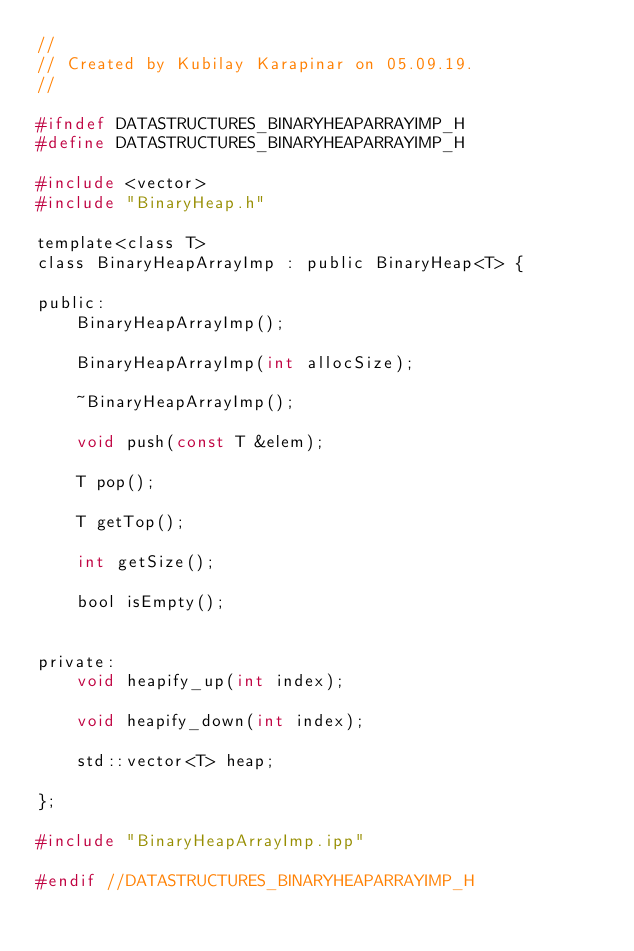Convert code to text. <code><loc_0><loc_0><loc_500><loc_500><_C_>//
// Created by Kubilay Karapinar on 05.09.19.
//

#ifndef DATASTRUCTURES_BINARYHEAPARRAYIMP_H
#define DATASTRUCTURES_BINARYHEAPARRAYIMP_H

#include <vector>
#include "BinaryHeap.h"

template<class T>
class BinaryHeapArrayImp : public BinaryHeap<T> {

public:
    BinaryHeapArrayImp();

    BinaryHeapArrayImp(int allocSize);

    ~BinaryHeapArrayImp();

    void push(const T &elem);

    T pop();

    T getTop();

    int getSize();

    bool isEmpty();


private:
    void heapify_up(int index);

    void heapify_down(int index);

    std::vector<T> heap;

};

#include "BinaryHeapArrayImp.ipp"

#endif //DATASTRUCTURES_BINARYHEAPARRAYIMP_H
</code> 